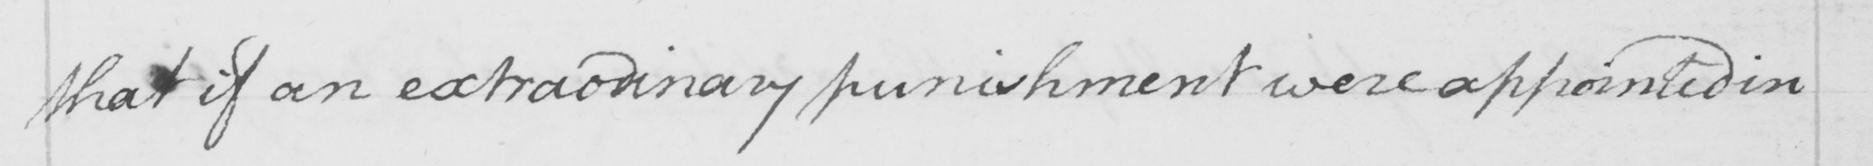Can you tell me what this handwritten text says? that if an extraodinary punishment were appointed in 